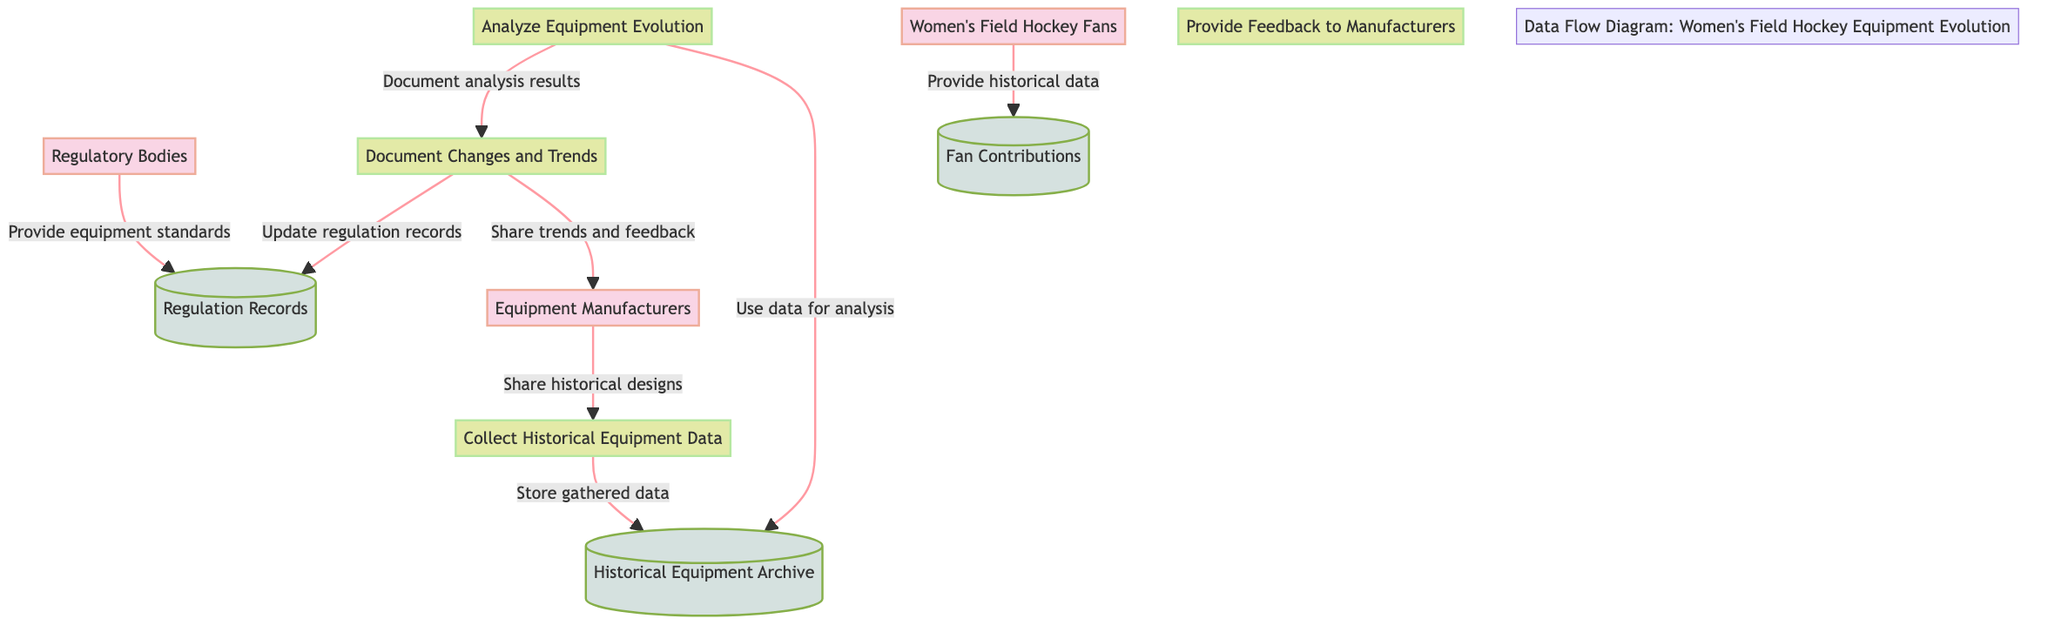What are the external entities involved in this diagram? The diagram includes three external entities: Women's Field Hockey Fans, Equipment Manufacturers, and Regulatory Bodies. These represent the different stakeholders contributing to the data flow regarding women's field hockey equipment.
Answer: Women's Field Hockey Fans, Equipment Manufacturers, Regulatory Bodies How many processes are represented in this diagram? There are four processes in the diagram: Collect Historical Equipment Data, Analyze Equipment Evolution, Document Changes and Trends, and Provide Feedback to Manufacturers. Counting these gives us a total of four distinct processes.
Answer: 4 What data store is used to keep fans' contributions? The data store for fan contributions is labeled as "Fan Contributions." It acts as a repository for historical data and personal observations provided by women's field hockey fans.
Answer: Fan Contributions Which external entity provides equipment standards? The external entity that provides equipment standards is the "Regulatory Bodies." This entity plays a crucial role in setting rules and standards for field hockey equipment.
Answer: Regulatory Bodies What is the first process in terms of data collection? The first process is "Collect Historical Equipment Data." This process initiates the gathering of information on various equipment used in women's field hockey over time.
Answer: Collect Historical Equipment Data How do Equipment Manufacturers contribute to the data flow? Equipment Manufacturers contribute by sharing historical designs and production details, which are inputs to the "Collect Historical Equipment Data" process in the diagram.
Answer: Share historical designs Which process is responsible for documenting analysis results? The process responsible for documenting analysis results is "Document Changes and Trends." After analyzing equipment evolution, this process consolidates the findings for further utilization.
Answer: Document Changes and Trends What is the outcome of the "Document Changes and Trends" process? The outcome of the "Document Changes and Trends" process includes sharing documented trends and feedback with Equipment Manufacturers and updating regulation records with documented changes.
Answer: Share trends and feedback, Update regulation records How is the "Historical Equipment Archive" utilized in equipment analysis? The "Historical Equipment Archive" serves as a critical data source for the "Analyze Equipment Evolution" process, which utilizes this gathered information to examine trends and changes in equipment over time.
Answer: Use data for analysis What type of information do Women's Field Hockey Fans provide? Women's Field Hockey Fans provide historical data and personal observations about equipment used in the sport, contributing valuable insights to the "Fan Contributions" data store.
Answer: Historical data and personal observations 